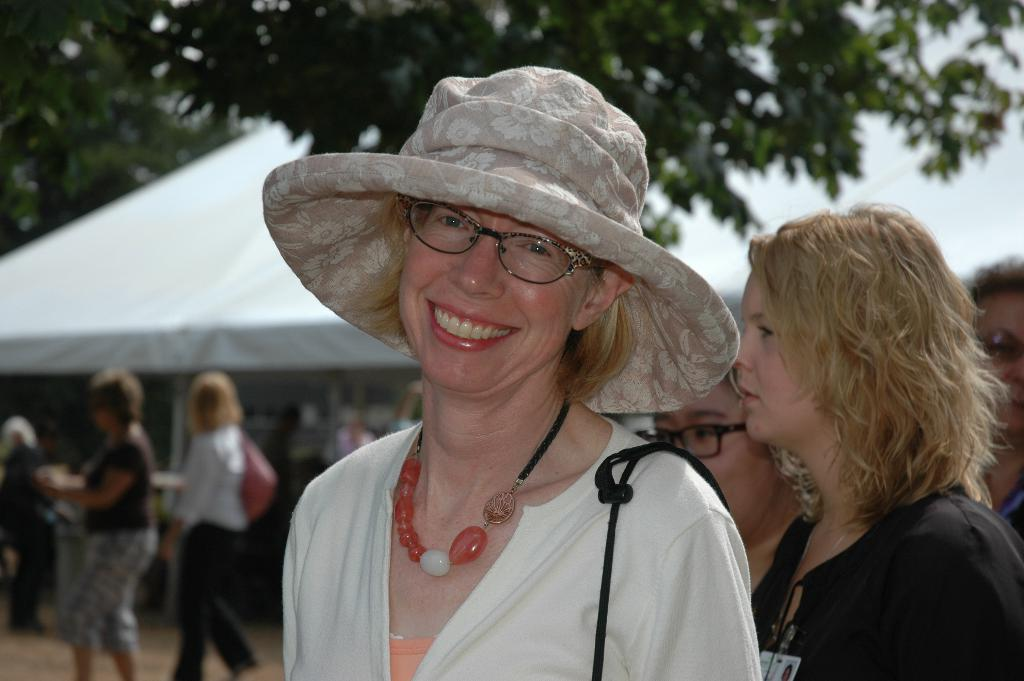What is the expression on the woman's face in the image? The woman in the image is smiling. What is the woman wearing on her head? The woman is wearing a hat. In which direction is the woman looking? The woman is looking forward. How would you describe the background of the image? The background of the image is blurred. What type of vegetation can be seen in the background? There is a tree visible in the background. What type of structure can be seen in the background? There is a tent in the background. Are there any other people visible in the image? Yes, there are people visible in the background. What type of quilt is being used to cover the woman in the image? There is no quilt present in the image; the woman is not covered by any fabric. What sound does the crack make in the image? There is no crack present in the image, so no sound can be heard. 